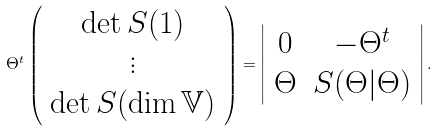<formula> <loc_0><loc_0><loc_500><loc_500>\Theta ^ { t } \left ( \begin{array} { c } \det S ( 1 ) \\ \vdots \\ \det S ( \dim \mathbb { V } ) \end{array} \right ) = \left | \begin{array} { c c } 0 & - \Theta ^ { t } \\ \Theta & S ( \Theta | \Theta ) \end{array} \right | .</formula> 